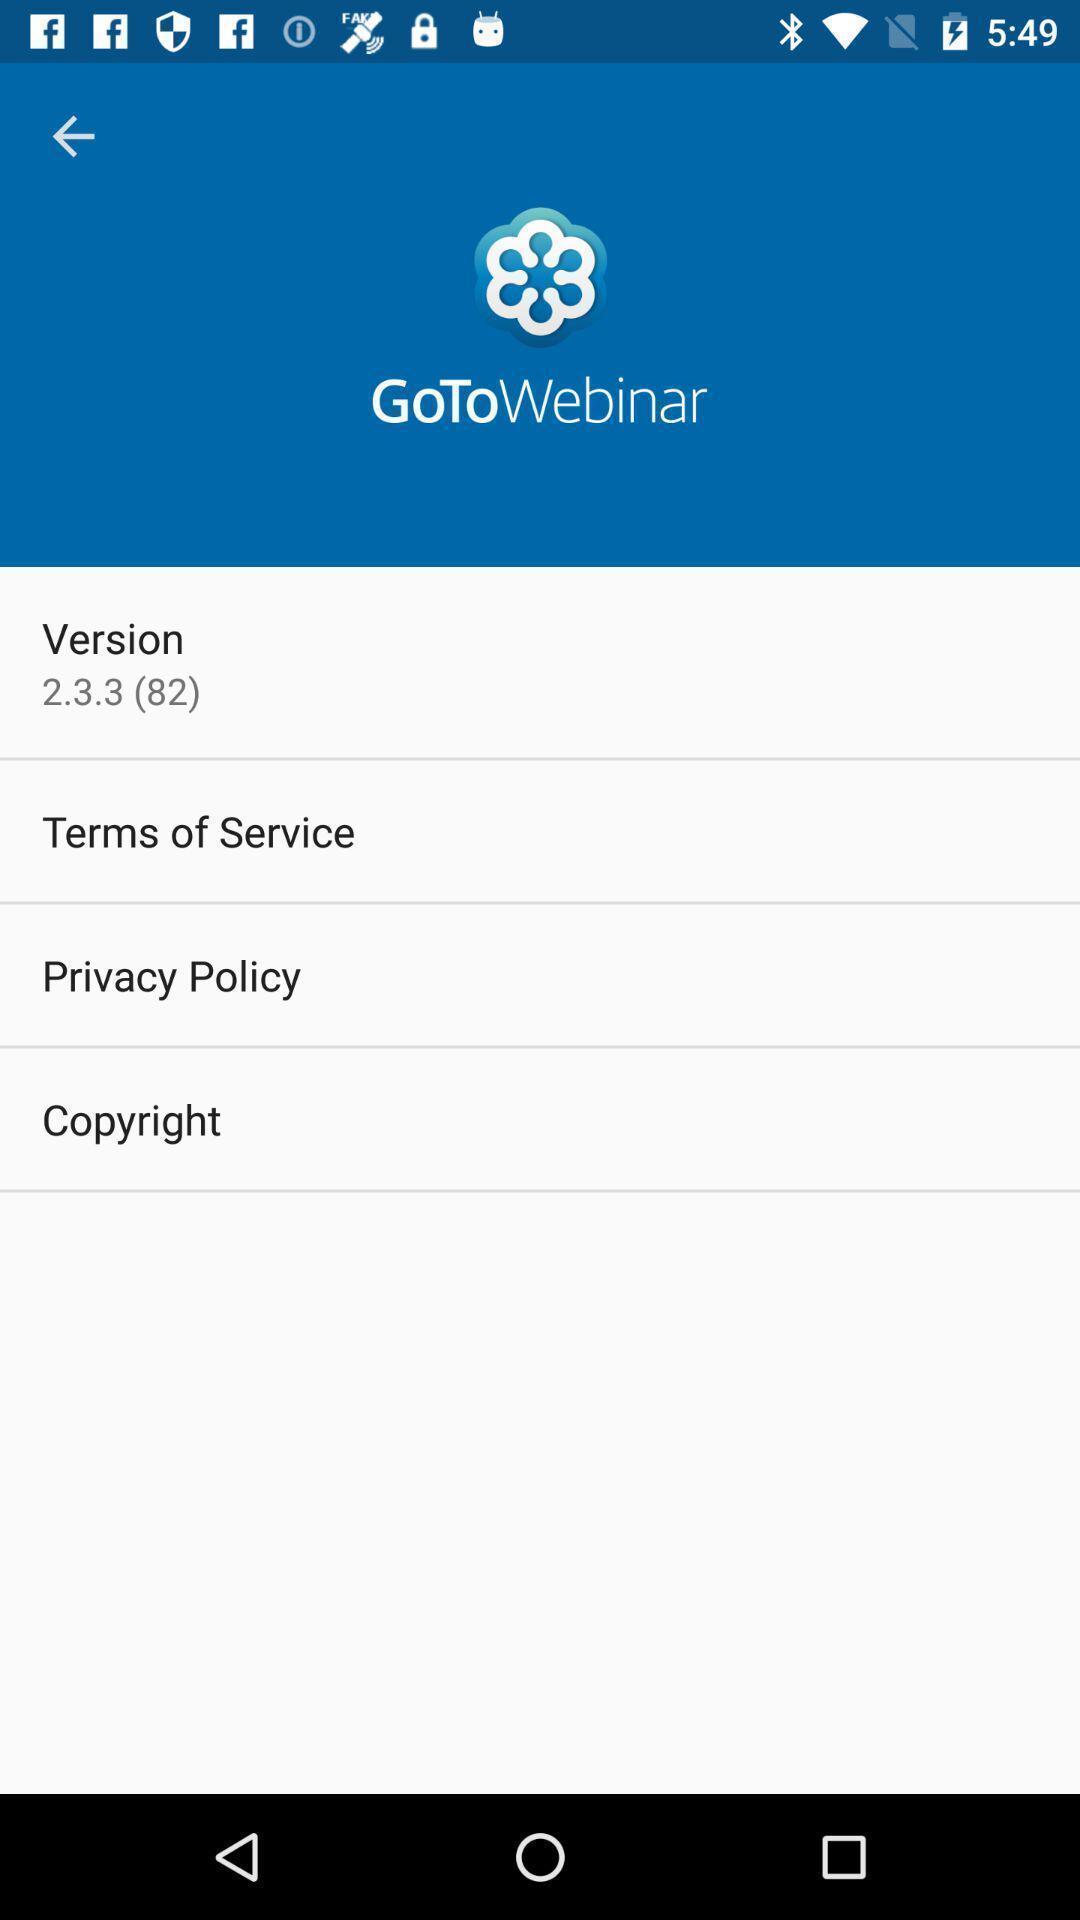Describe the content in this image. Screen shows version details. 